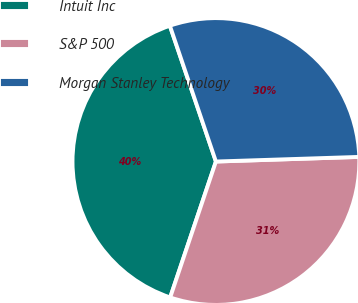Convert chart to OTSL. <chart><loc_0><loc_0><loc_500><loc_500><pie_chart><fcel>Intuit Inc<fcel>S&P 500<fcel>Morgan Stanley Technology<nl><fcel>39.63%<fcel>30.68%<fcel>29.69%<nl></chart> 